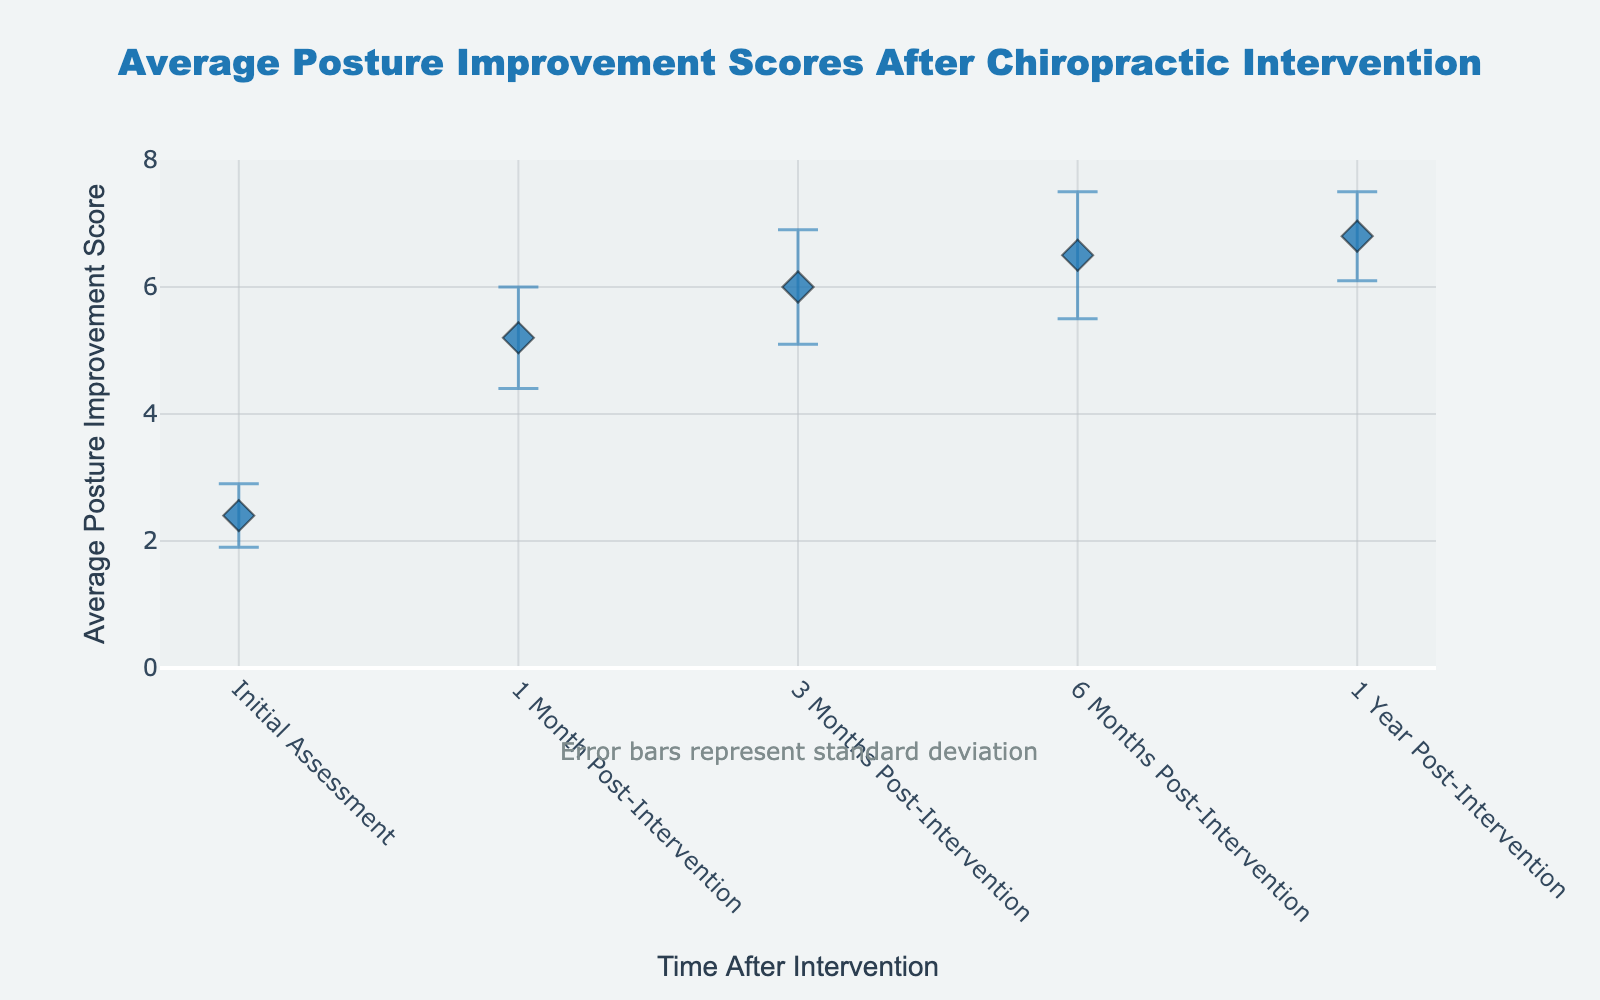what is the title of the plot? The title of the plot is displayed at the top center. It reads "Average Posture Improvement Scores After Chiropractic Intervention".
Answer: Average Posture Improvement Scores After Chiropractic Intervention How many time points are evaluated in the plot? The x-axis shows the time points. There are five time points listed: Initial Assessment, 1 Month Post-Intervention, 3 Months Post-Intervention, 6 Months Post-Intervention, and 1 Year Post-Intervention.
Answer: 5 What is the Average Posture Improvement Score at 1 Year Post-Intervention? Locate the point on the plot corresponding to 1 Year Post-Intervention along the x-axis and read the corresponding value on the y-axis. The score is 6.8.
Answer: 6.8 Which time point has the lowest Average Posture Improvement Score? Compare the scores along the y-axis for each time point. The lowest score is at the Initial Assessment, which is 2.4.
Answer: Initial Assessment By how much does the Average Posture Improvement Score increase from the Initial Assessment to 1 Month Post-Intervention? Subtract the score at the Initial Assessment (2.4) from the score at 1 Month Post-Intervention (5.2). The increase is 5.2 - 2.4 = 2.8.
Answer: 2.8 Are there any time points with a lower standard deviation than the Initial Assessment? The Initial Assessment has a standard deviation of 0.5. Compare this with the other standard deviations: 0.8, 0.9, 1.0, and 0.7. Only 1 Year Post-Intervention has a lower standard deviation (0.7).
Answer: Yes What is the largest standard deviation shown in the plot? Identify the time point with the highest error bar. The maximum standard deviation is 1.0, observed at 6 Months Post-Intervention.
Answer: 1.0 Does the Average Posture Improvement Score continually increase over time? Observe the trend of the Average Posture Improvement Scores: Initial Assessment (2.4), 1 Month (5.2), 3 Months (6.0), 6 Months (6.5), and 1 Year (6.8). The scores increase steadily over time.
Answer: Yes What is the average improvement score from 1 Month Post-Intervention to 1 Year Post-Intervention? Add the scores from 1 Month (5.2), 3 Months (6.0), 6 Months (6.5), and 1 Year (6.8). Then divide by 4. The sum is 24.5, and the average is 24.5 / 4 = 6.125.
Answer: 6.125 By how much does the standard deviation change from 3 Months Post-Intervention to 6 Months Post-Intervention? Subtract the standard deviation at 3 Months (0.9) from the standard deviation at 6 Months (1.0). The change is 1.0 - 0.9 = 0.1.
Answer: 0.1 